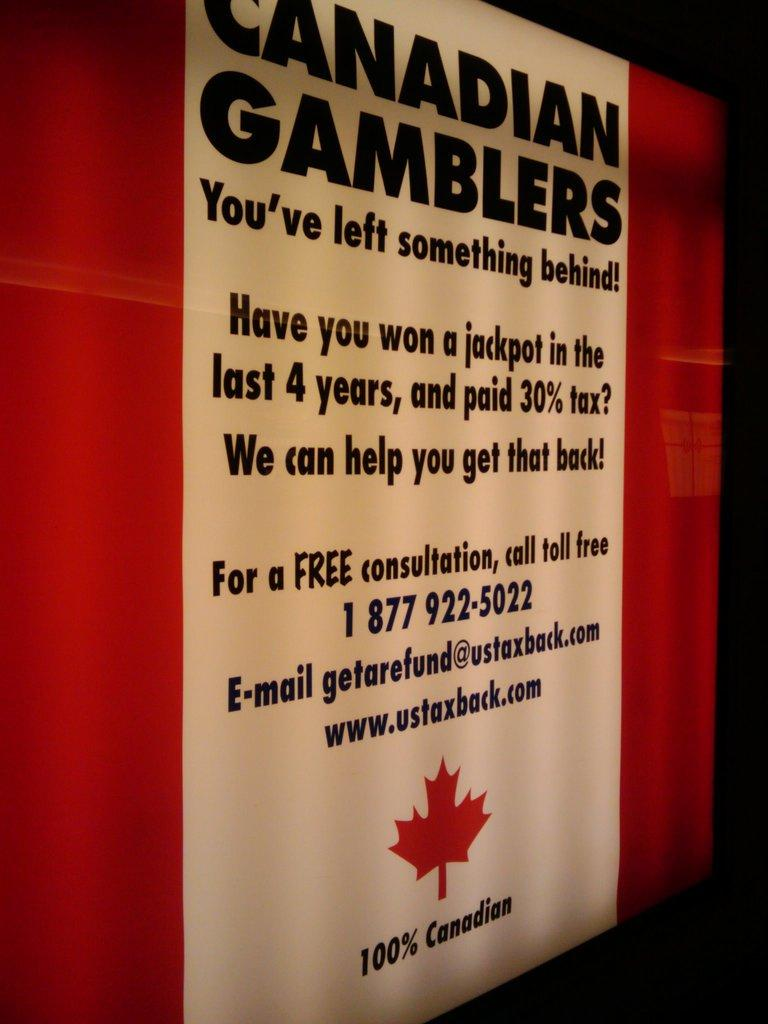<image>
Write a terse but informative summary of the picture. A sign is asking Canadian gamblers if they have left something behind. 